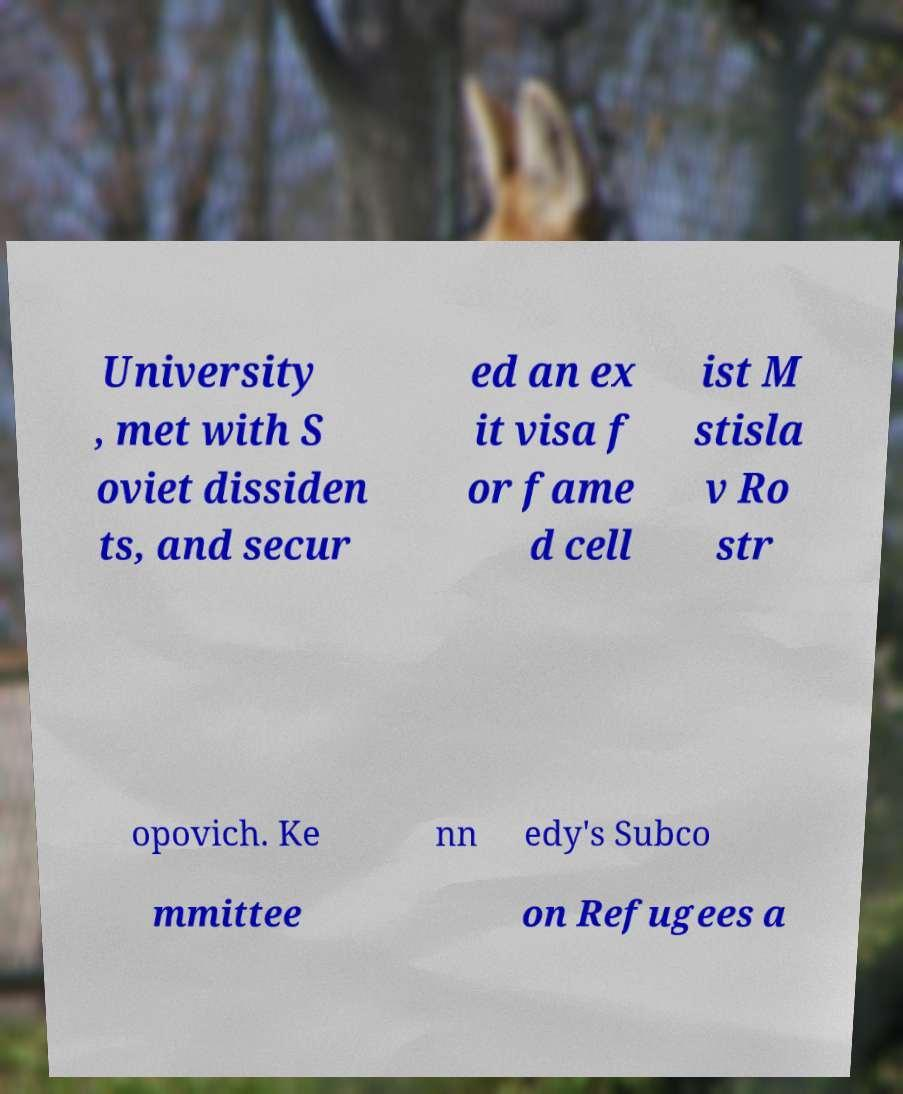I need the written content from this picture converted into text. Can you do that? University , met with S oviet dissiden ts, and secur ed an ex it visa f or fame d cell ist M stisla v Ro str opovich. Ke nn edy's Subco mmittee on Refugees a 